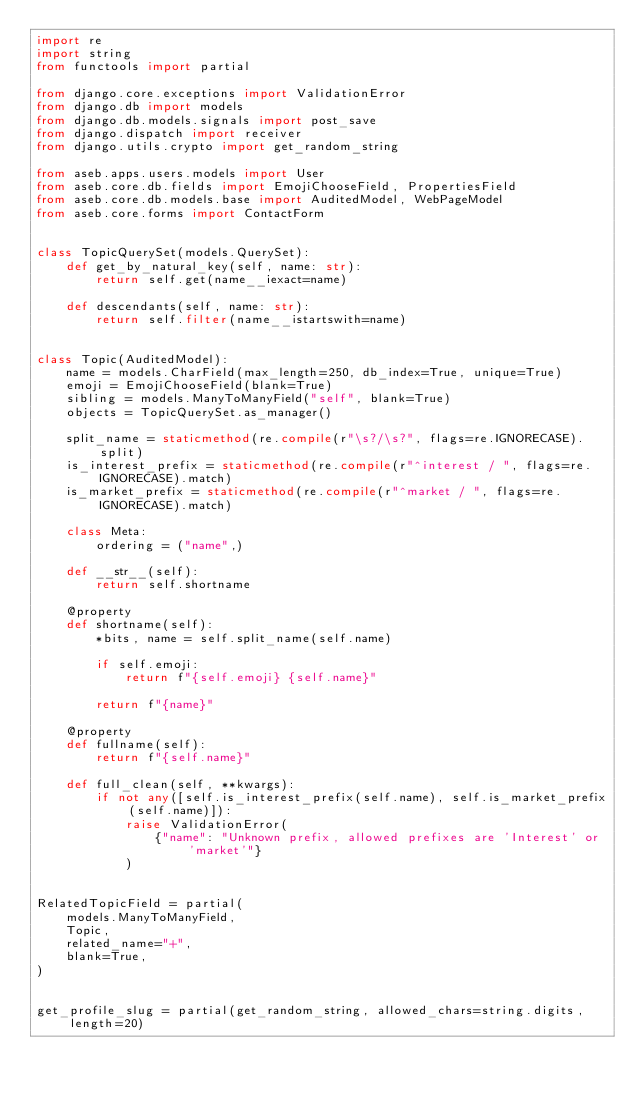Convert code to text. <code><loc_0><loc_0><loc_500><loc_500><_Python_>import re
import string
from functools import partial

from django.core.exceptions import ValidationError
from django.db import models
from django.db.models.signals import post_save
from django.dispatch import receiver
from django.utils.crypto import get_random_string

from aseb.apps.users.models import User
from aseb.core.db.fields import EmojiChooseField, PropertiesField
from aseb.core.db.models.base import AuditedModel, WebPageModel
from aseb.core.forms import ContactForm


class TopicQuerySet(models.QuerySet):
    def get_by_natural_key(self, name: str):
        return self.get(name__iexact=name)

    def descendants(self, name: str):
        return self.filter(name__istartswith=name)


class Topic(AuditedModel):
    name = models.CharField(max_length=250, db_index=True, unique=True)
    emoji = EmojiChooseField(blank=True)
    sibling = models.ManyToManyField("self", blank=True)
    objects = TopicQuerySet.as_manager()

    split_name = staticmethod(re.compile(r"\s?/\s?", flags=re.IGNORECASE).split)
    is_interest_prefix = staticmethod(re.compile(r"^interest / ", flags=re.IGNORECASE).match)
    is_market_prefix = staticmethod(re.compile(r"^market / ", flags=re.IGNORECASE).match)

    class Meta:
        ordering = ("name",)

    def __str__(self):
        return self.shortname

    @property
    def shortname(self):
        *bits, name = self.split_name(self.name)

        if self.emoji:
            return f"{self.emoji} {self.name}"

        return f"{name}"

    @property
    def fullname(self):
        return f"{self.name}"

    def full_clean(self, **kwargs):
        if not any([self.is_interest_prefix(self.name), self.is_market_prefix(self.name)]):
            raise ValidationError(
                {"name": "Unknown prefix, allowed prefixes are 'Interest' or 'market'"}
            )


RelatedTopicField = partial(
    models.ManyToManyField,
    Topic,
    related_name="+",
    blank=True,
)


get_profile_slug = partial(get_random_string, allowed_chars=string.digits, length=20)

</code> 